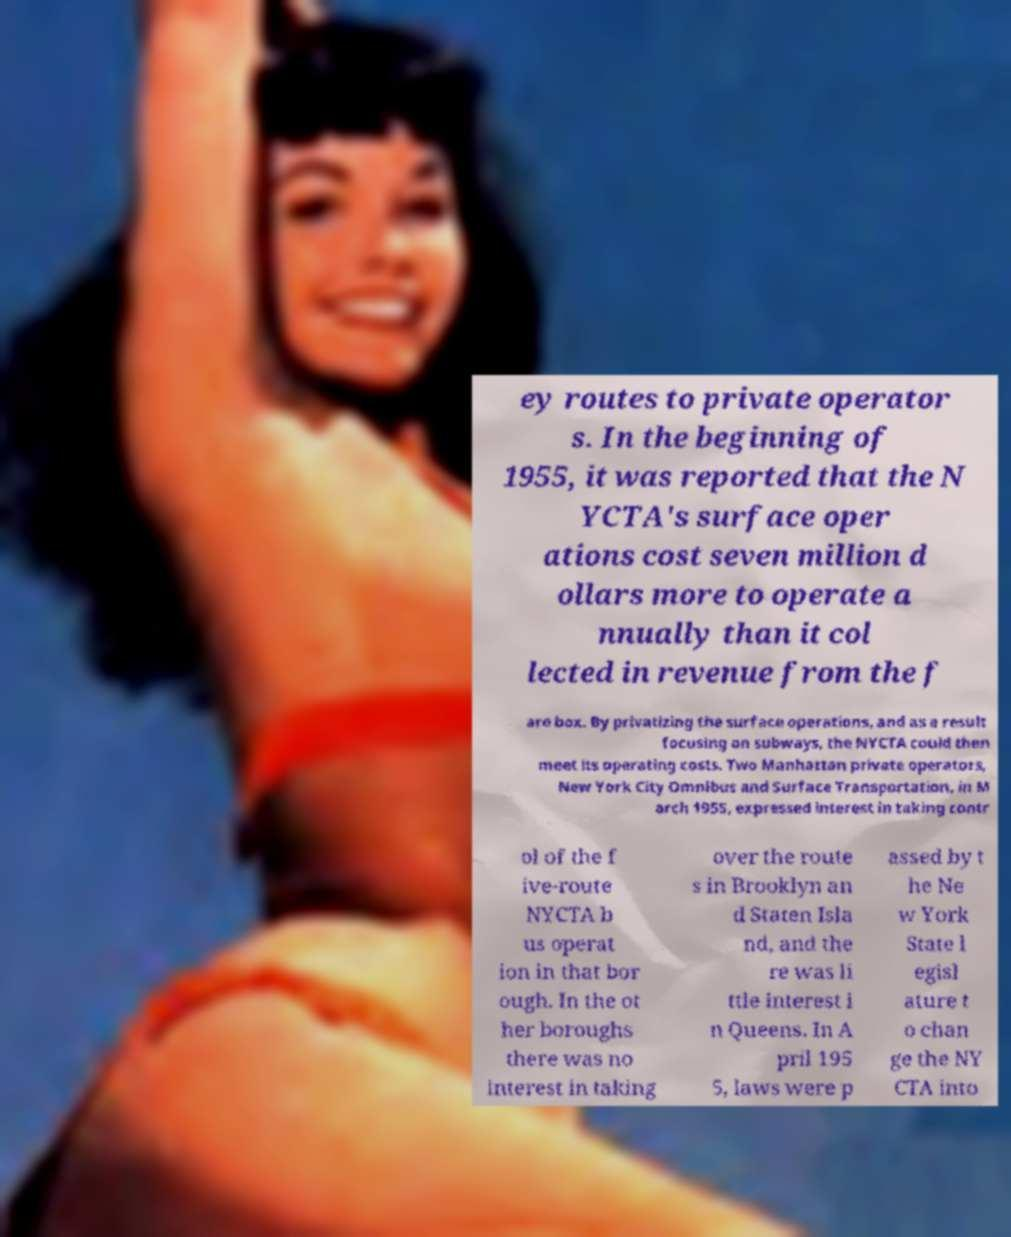I need the written content from this picture converted into text. Can you do that? ey routes to private operator s. In the beginning of 1955, it was reported that the N YCTA's surface oper ations cost seven million d ollars more to operate a nnually than it col lected in revenue from the f are box. By privatizing the surface operations, and as a result focusing on subways, the NYCTA could then meet its operating costs. Two Manhattan private operators, New York City Omnibus and Surface Transportation, in M arch 1955, expressed interest in taking contr ol of the f ive-route NYCTA b us operat ion in that bor ough. In the ot her boroughs there was no interest in taking over the route s in Brooklyn an d Staten Isla nd, and the re was li ttle interest i n Queens. In A pril 195 5, laws were p assed by t he Ne w York State l egisl ature t o chan ge the NY CTA into 